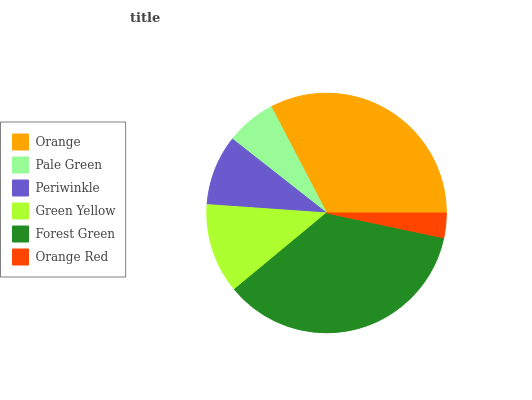Is Orange Red the minimum?
Answer yes or no. Yes. Is Forest Green the maximum?
Answer yes or no. Yes. Is Pale Green the minimum?
Answer yes or no. No. Is Pale Green the maximum?
Answer yes or no. No. Is Orange greater than Pale Green?
Answer yes or no. Yes. Is Pale Green less than Orange?
Answer yes or no. Yes. Is Pale Green greater than Orange?
Answer yes or no. No. Is Orange less than Pale Green?
Answer yes or no. No. Is Green Yellow the high median?
Answer yes or no. Yes. Is Periwinkle the low median?
Answer yes or no. Yes. Is Orange Red the high median?
Answer yes or no. No. Is Pale Green the low median?
Answer yes or no. No. 